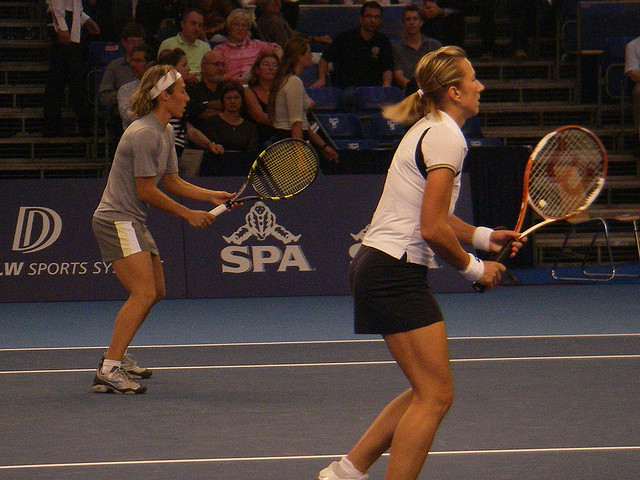Identify and read out the text in this image. D W SPORTS SY SPA 